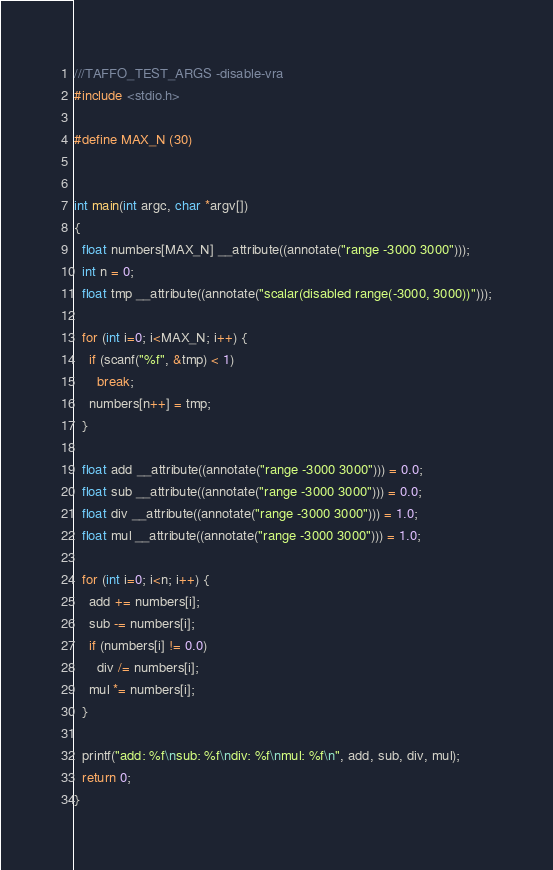<code> <loc_0><loc_0><loc_500><loc_500><_C_>///TAFFO_TEST_ARGS -disable-vra
#include <stdio.h>

#define MAX_N (30)


int main(int argc, char *argv[])
{
  float numbers[MAX_N] __attribute((annotate("range -3000 3000")));
  int n = 0;
  float tmp __attribute((annotate("scalar(disabled range(-3000, 3000))")));
  
  for (int i=0; i<MAX_N; i++) {
    if (scanf("%f", &tmp) < 1)
      break;
    numbers[n++] = tmp;
  }
  
  float add __attribute((annotate("range -3000 3000"))) = 0.0;
  float sub __attribute((annotate("range -3000 3000"))) = 0.0;
  float div __attribute((annotate("range -3000 3000"))) = 1.0;
  float mul __attribute((annotate("range -3000 3000"))) = 1.0;
  
  for (int i=0; i<n; i++) {
    add += numbers[i];
    sub -= numbers[i];
    if (numbers[i] != 0.0)
      div /= numbers[i];
    mul *= numbers[i];
  }
  
  printf("add: %f\nsub: %f\ndiv: %f\nmul: %f\n", add, sub, div, mul);
  return 0;
}


</code> 